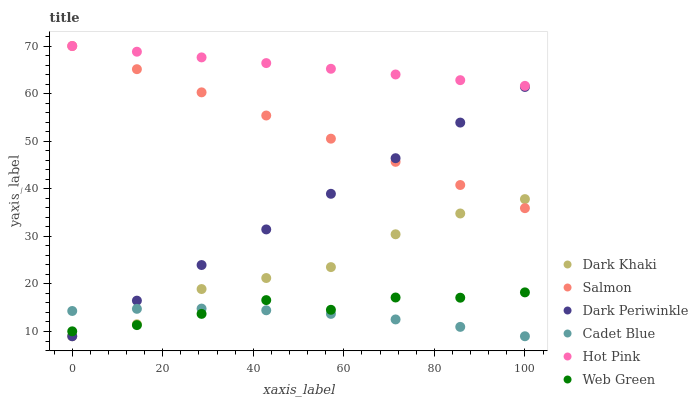Does Cadet Blue have the minimum area under the curve?
Answer yes or no. Yes. Does Hot Pink have the maximum area under the curve?
Answer yes or no. Yes. Does Salmon have the minimum area under the curve?
Answer yes or no. No. Does Salmon have the maximum area under the curve?
Answer yes or no. No. Is Dark Periwinkle the smoothest?
Answer yes or no. Yes. Is Dark Khaki the roughest?
Answer yes or no. Yes. Is Hot Pink the smoothest?
Answer yes or no. No. Is Hot Pink the roughest?
Answer yes or no. No. Does Cadet Blue have the lowest value?
Answer yes or no. Yes. Does Salmon have the lowest value?
Answer yes or no. No. Does Salmon have the highest value?
Answer yes or no. Yes. Does Web Green have the highest value?
Answer yes or no. No. Is Dark Periwinkle less than Hot Pink?
Answer yes or no. Yes. Is Hot Pink greater than Cadet Blue?
Answer yes or no. Yes. Does Dark Khaki intersect Dark Periwinkle?
Answer yes or no. Yes. Is Dark Khaki less than Dark Periwinkle?
Answer yes or no. No. Is Dark Khaki greater than Dark Periwinkle?
Answer yes or no. No. Does Dark Periwinkle intersect Hot Pink?
Answer yes or no. No. 